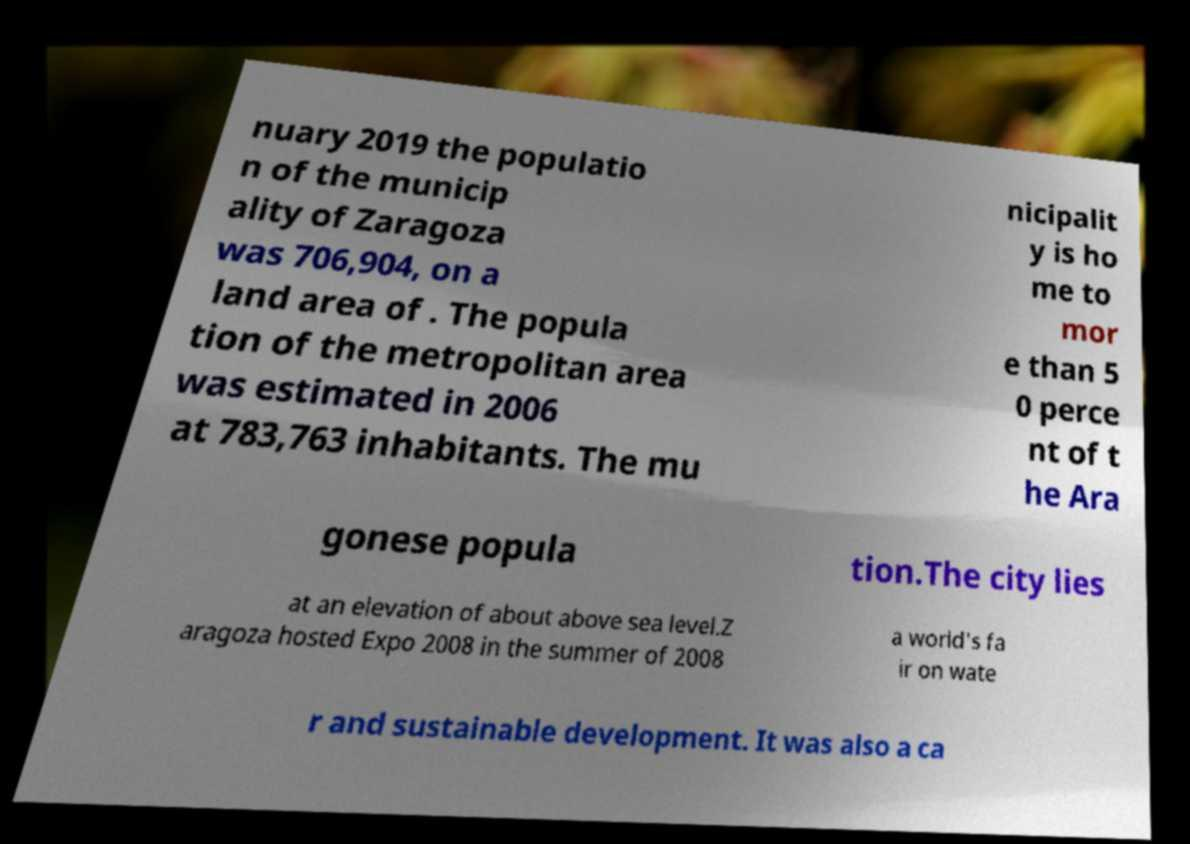I need the written content from this picture converted into text. Can you do that? nuary 2019 the populatio n of the municip ality of Zaragoza was 706,904, on a land area of . The popula tion of the metropolitan area was estimated in 2006 at 783,763 inhabitants. The mu nicipalit y is ho me to mor e than 5 0 perce nt of t he Ara gonese popula tion.The city lies at an elevation of about above sea level.Z aragoza hosted Expo 2008 in the summer of 2008 a world's fa ir on wate r and sustainable development. It was also a ca 